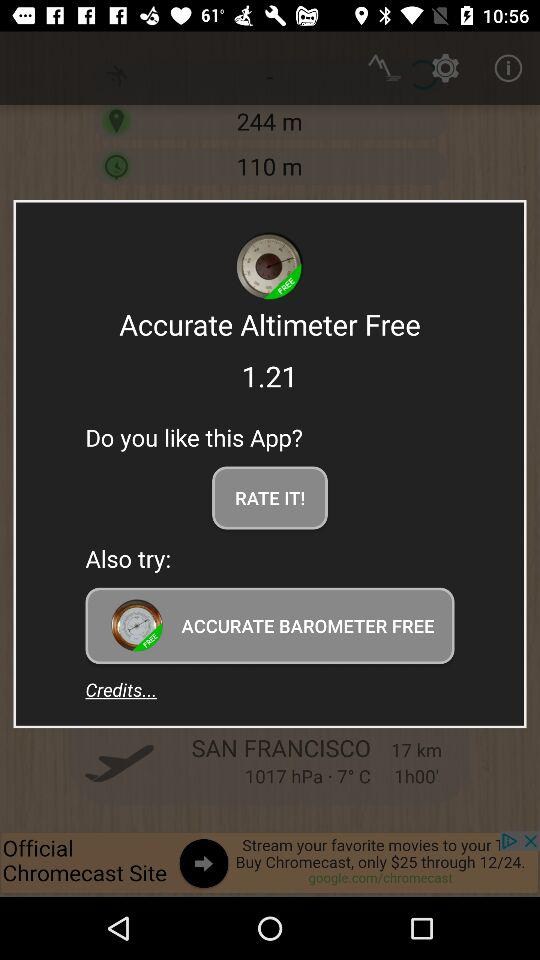What is the name of the application? The name of the application is "Accurate Altimeter Free". 